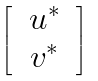<formula> <loc_0><loc_0><loc_500><loc_500>\begin{bmatrix} & u ^ { * } & \\ & v ^ { * } & \end{bmatrix}</formula> 